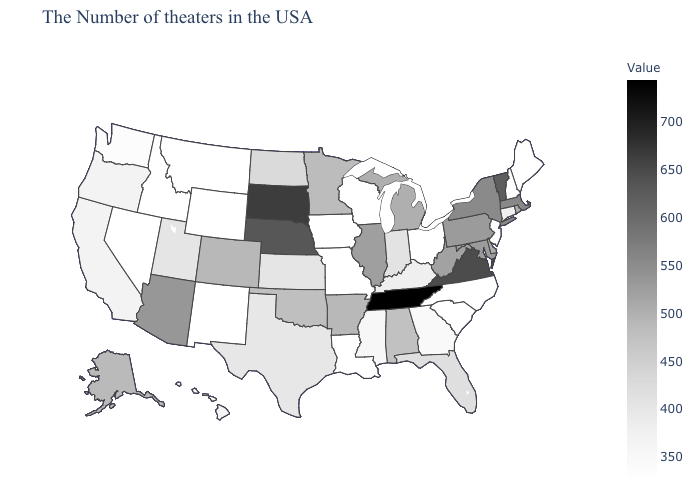Among the states that border Vermont , which have the lowest value?
Be succinct. New Hampshire. Which states hav the highest value in the MidWest?
Give a very brief answer. South Dakota. Among the states that border Utah , which have the lowest value?
Answer briefly. Wyoming, New Mexico, Idaho, Nevada. Among the states that border Kentucky , does Illinois have the lowest value?
Give a very brief answer. No. 